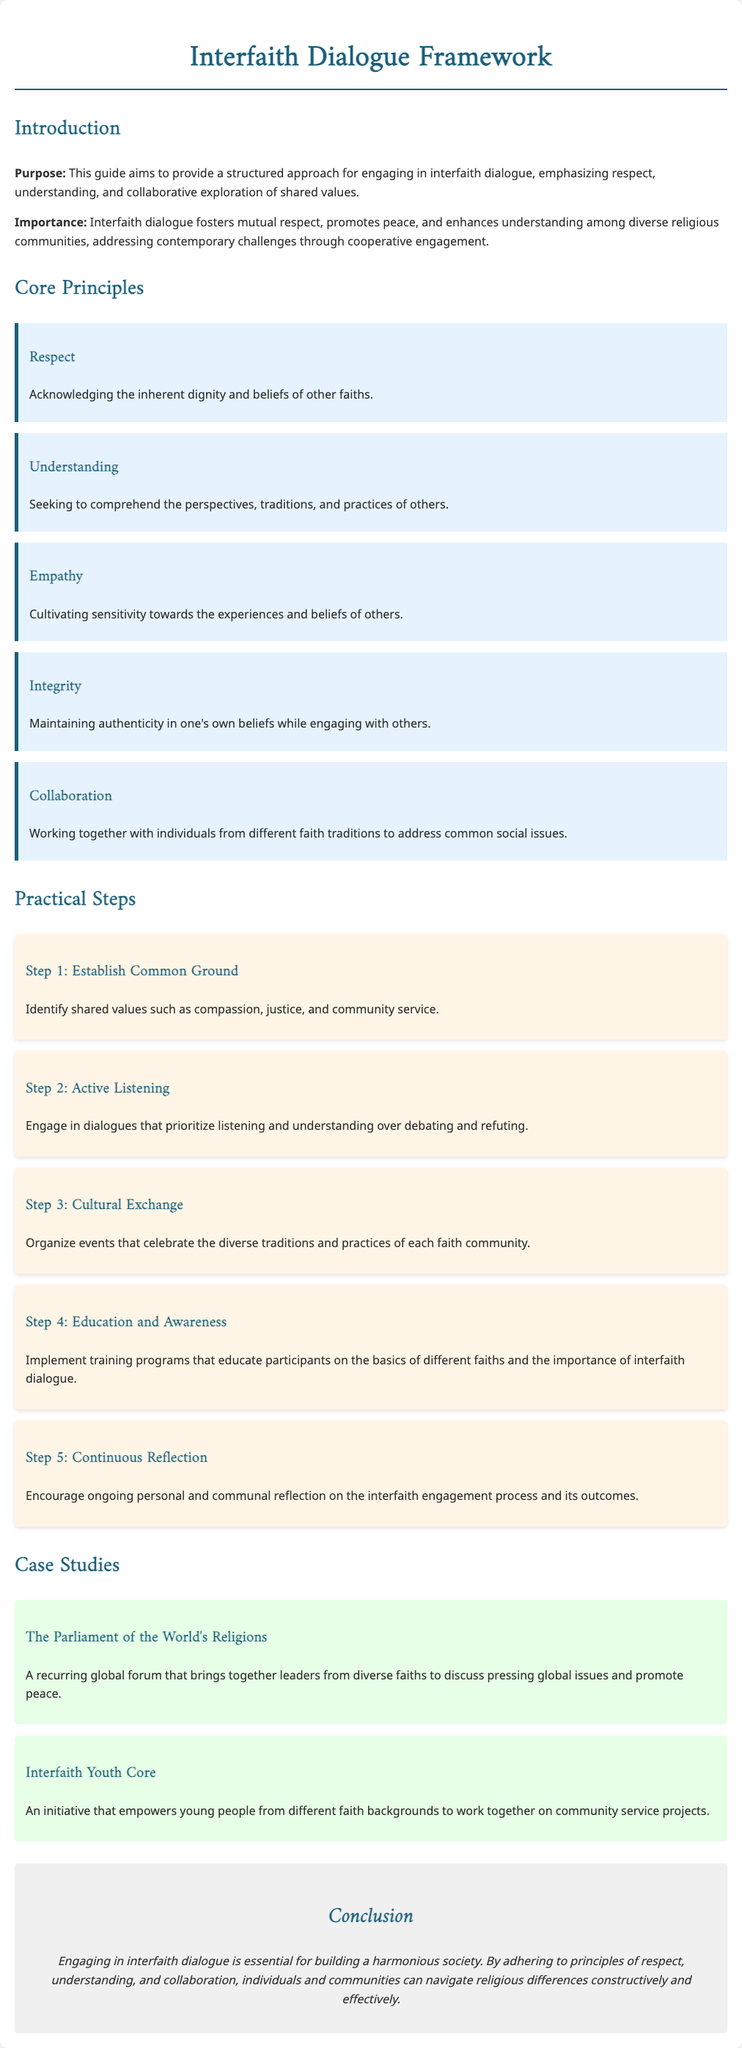what is the purpose of this guide? The purpose of this guide is to provide a structured approach for engaging in interfaith dialogue, emphasizing respect, understanding, and collaborative exploration of shared values.
Answer: structured approach for engaging in interfaith dialogue what is one of the core principles? Core principles emphasize key values essential for interfaith dialogue, one of which is respect, acknowledging the inherent dignity and beliefs of other faiths.
Answer: respect how many practical steps are outlined in the document? The document outlines five practical steps to facilitate interfaith dialogue effectively.
Answer: five what is the name of an initiative that empowers young people for community projects? An initiative mentioned in the document that empowers young people from different faith backgrounds is the Interfaith Youth Core.
Answer: Interfaith Youth Core what is the background color used for the principle section? The principle section of the document uses a light blue background color as indicated by the design.
Answer: light blue why is empathy important in interfaith dialogue? Empathy cultivates sensitivity towards the experiences and beliefs of others, which is essential for fostering understanding and respect in dialogue.
Answer: sensitivity towards experiences and beliefs what event brings together leaders from diverse faiths? The Parliament of the World's Religions is highlighted in the case studies as an event that brings together leaders from diverse faiths.
Answer: The Parliament of the World's Religions what is step 2 in the practical steps? Step 2 focuses on active listening, which prioritizes listening and understanding over debating and refuting during dialogues.
Answer: Active Listening 